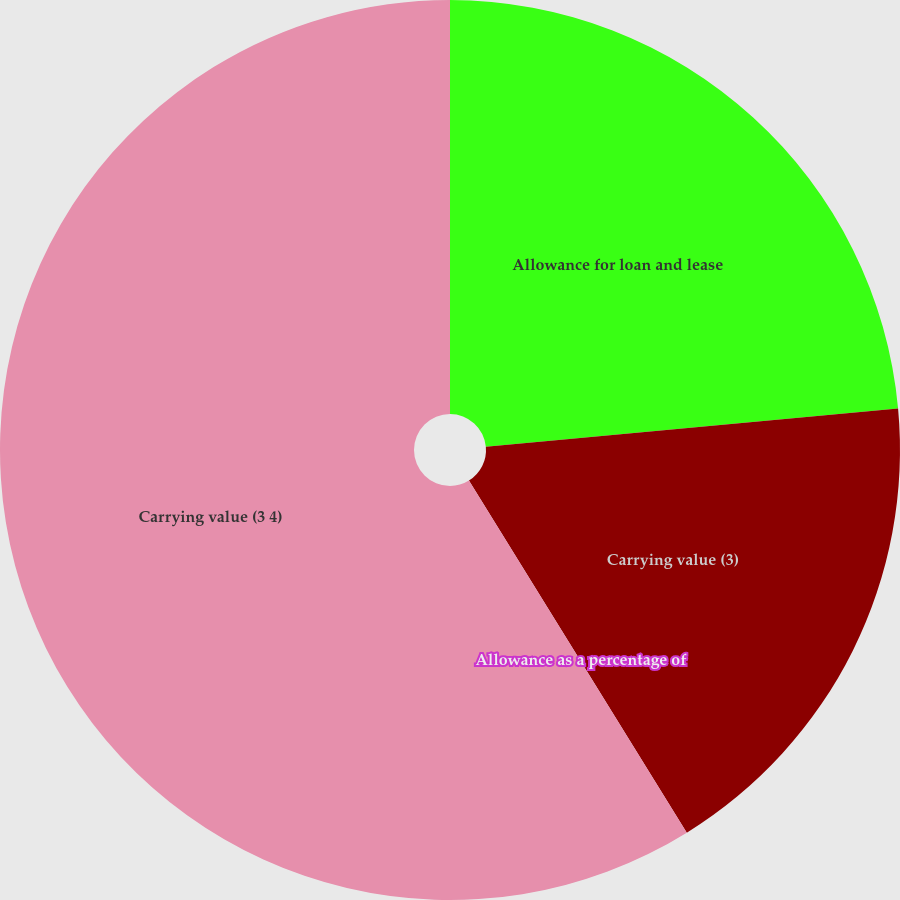Convert chart to OTSL. <chart><loc_0><loc_0><loc_500><loc_500><pie_chart><fcel>Allowance for loan and lease<fcel>Carrying value (3)<fcel>Allowance as a percentage of<fcel>Carrying value (3 4)<nl><fcel>23.53%<fcel>17.65%<fcel>0.0%<fcel>58.82%<nl></chart> 